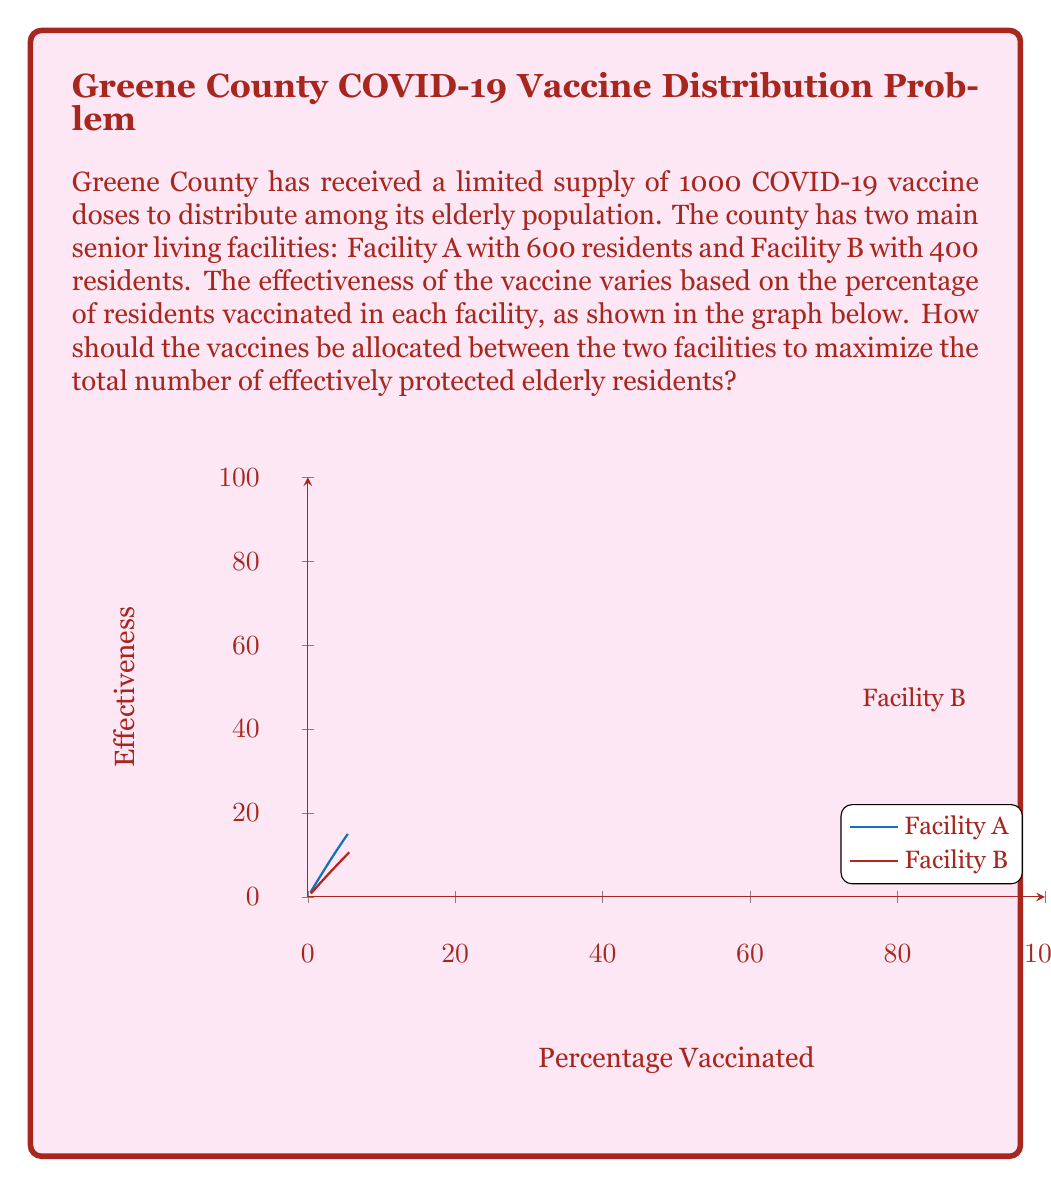Show me your answer to this math problem. To solve this optimization problem, we need to follow these steps:

1) Let $x$ be the number of vaccines allocated to Facility A, and $(1000-x)$ be the number allocated to Facility B.

2) The effectiveness functions for each facility are:
   Facility A: $f_A(x) = 600 \cdot (1 - e^{-0.03x/600})$
   Facility B: $f_B(x) = 400 \cdot (1 - e^{-0.02(1000-x)/400})$

3) The total number of effectively protected residents is:
   $F(x) = f_A(x) + f_B(x)$

4) To find the maximum, we need to differentiate $F(x)$ and set it to zero:

   $$F'(x) = 600 \cdot 0.03/600 \cdot e^{-0.03x/600} + 400 \cdot 0.02/400 \cdot e^{-0.02(1000-x)/400} = 0$$

5) Simplifying:

   $$0.03e^{-0.03x/600} = 0.02e^{-0.02(1000-x)/400}$$

6) Taking natural log of both sides:

   $$\ln(0.03) - 0.03x/600 = \ln(0.02) - 0.02(1000-x)/400$$

7) Solving for $x$:

   $$x \approx 638.2$$

8) Rounding to the nearest whole number (as we can't allocate partial vaccines):

   $x = 638$ vaccines should be allocated to Facility A, and $1000 - 638 = 362$ to Facility B.

9) This allocation results in approximately 495 effectively protected residents in Facility A and 295 in Facility B, for a total of 790 effectively protected elderly residents.
Answer: Allocate 638 vaccines to Facility A and 362 to Facility B. 